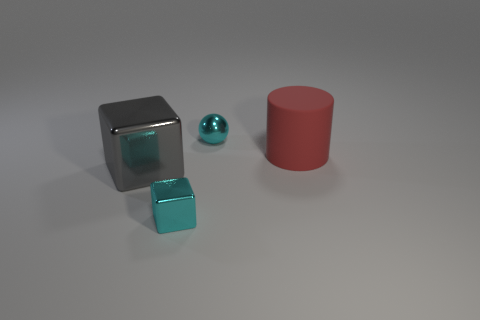Are there fewer cylinders right of the big red matte thing than cubes on the left side of the large gray thing?
Provide a short and direct response. No. What number of things are either big cyan cylinders or things behind the big gray metallic object?
Your answer should be compact. 2. There is a block that is the same size as the red rubber cylinder; what is it made of?
Your response must be concise. Metal. Is the material of the large cylinder the same as the sphere?
Provide a short and direct response. No. The object that is left of the cylinder and behind the big metallic thing is what color?
Your response must be concise. Cyan. Does the large object in front of the large red object have the same color as the tiny block?
Give a very brief answer. No. What shape is the red rubber thing that is the same size as the gray shiny object?
Keep it short and to the point. Cylinder. What number of other objects are there of the same color as the ball?
Offer a terse response. 1. What number of other things are made of the same material as the cyan sphere?
Your response must be concise. 2. There is a gray cube; is it the same size as the cyan metallic object that is in front of the large metal object?
Your answer should be compact. No. 